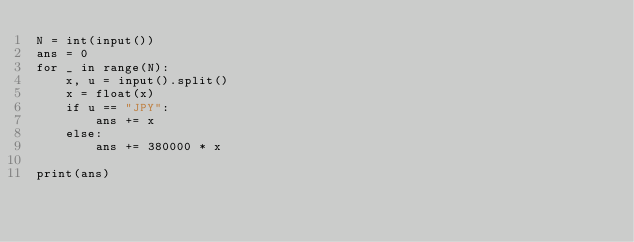Convert code to text. <code><loc_0><loc_0><loc_500><loc_500><_Python_>N = int(input())
ans = 0
for _ in range(N):
    x, u = input().split()
    x = float(x)
    if u == "JPY":    
        ans += x
    else:
        ans += 380000 * x
        
print(ans)</code> 